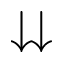<formula> <loc_0><loc_0><loc_500><loc_500>\downdownarrows</formula> 